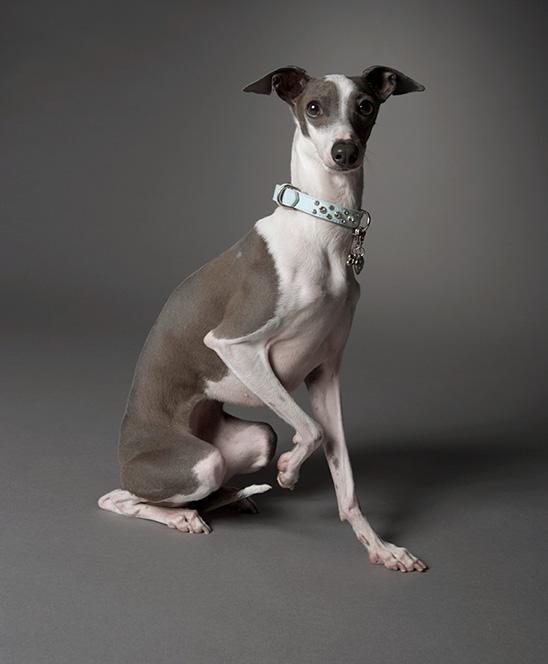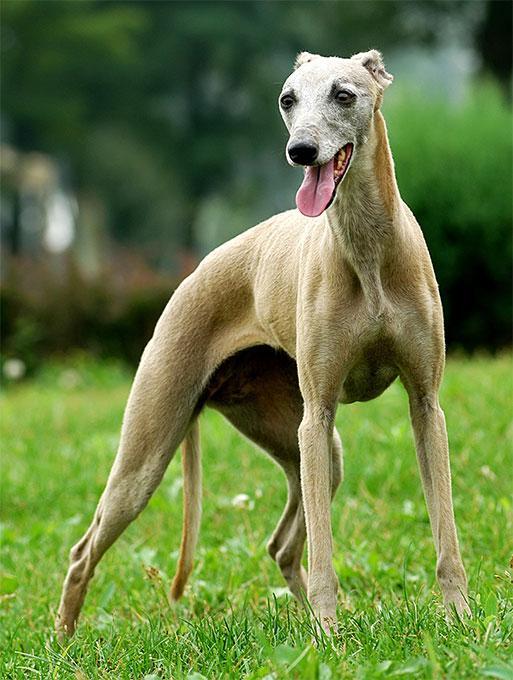The first image is the image on the left, the second image is the image on the right. Examine the images to the left and right. Is the description "An image shows a gray and white hound wearing a collar with a charm attached." accurate? Answer yes or no. Yes. The first image is the image on the left, the second image is the image on the right. Examine the images to the left and right. Is the description "In one image, a gray and white dog with ears that point to the side is wearing a collar with a dangling charm." accurate? Answer yes or no. Yes. 